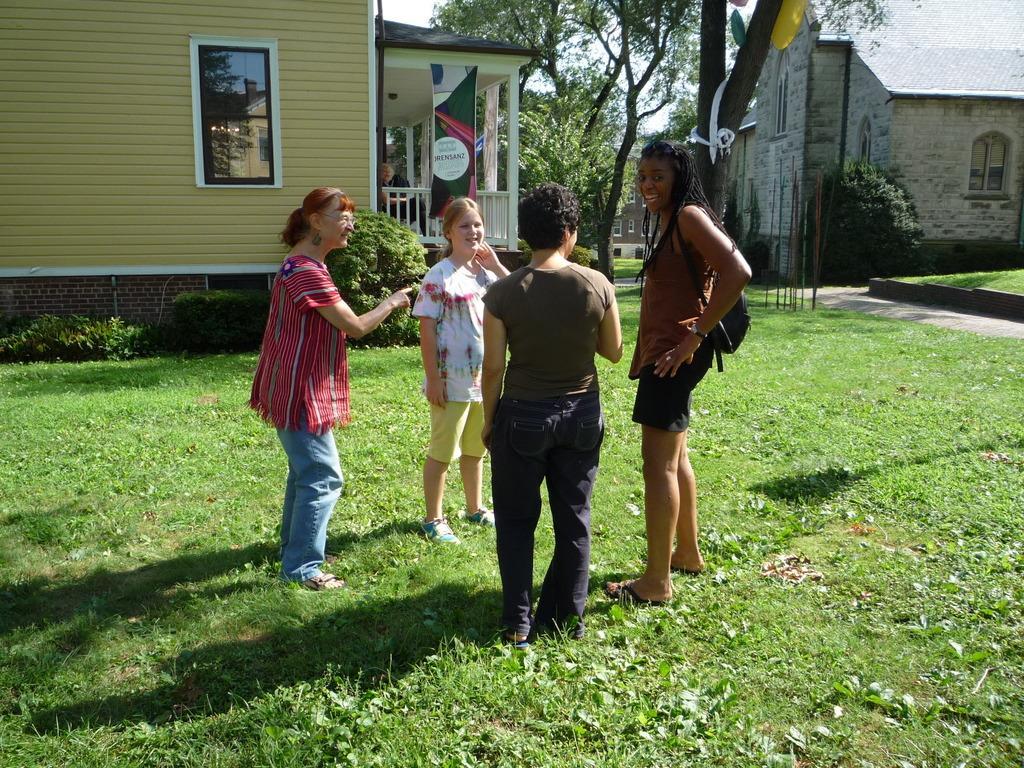How would you summarize this image in a sentence or two? In this picture I can observe four women standing on the ground. There is some grass on the ground. In the background I can observe houses and trees. 